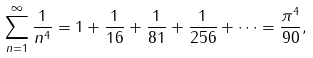Convert formula to latex. <formula><loc_0><loc_0><loc_500><loc_500>\sum ^ { \infty } _ { n = 1 } \frac { 1 } { n ^ { 4 } } = 1 + \frac { 1 } { 1 6 } + \frac { 1 } { 8 1 } + \frac { 1 } { 2 5 6 } + \dots = \frac { \pi ^ { 4 } } { 9 0 } ,</formula> 